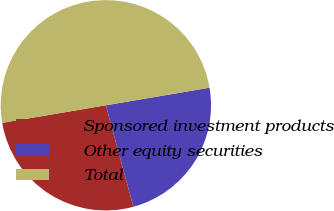Convert chart to OTSL. <chart><loc_0><loc_0><loc_500><loc_500><pie_chart><fcel>Sponsored investment products<fcel>Other equity securities<fcel>Total<nl><fcel>26.54%<fcel>23.46%<fcel>50.0%<nl></chart> 